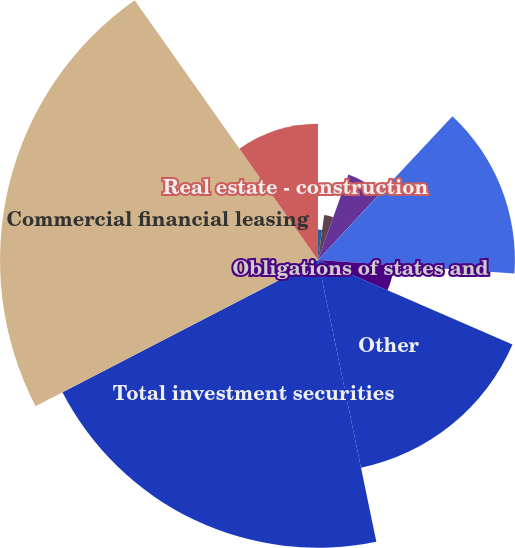Convert chart. <chart><loc_0><loc_0><loc_500><loc_500><pie_chart><fcel>Interest-bearing deposits at<fcel>Federal funds sold and resell<fcel>Trading account<fcel>Total money-market assets<fcel>US Treasury and federal<fcel>Obligations of states and<fcel>Other<fcel>Total investment securities<fcel>Commercial financial leasing<fcel>Real estate - construction<nl><fcel>0.0%<fcel>2.18%<fcel>3.26%<fcel>6.52%<fcel>14.13%<fcel>5.44%<fcel>15.22%<fcel>20.65%<fcel>22.82%<fcel>9.78%<nl></chart> 